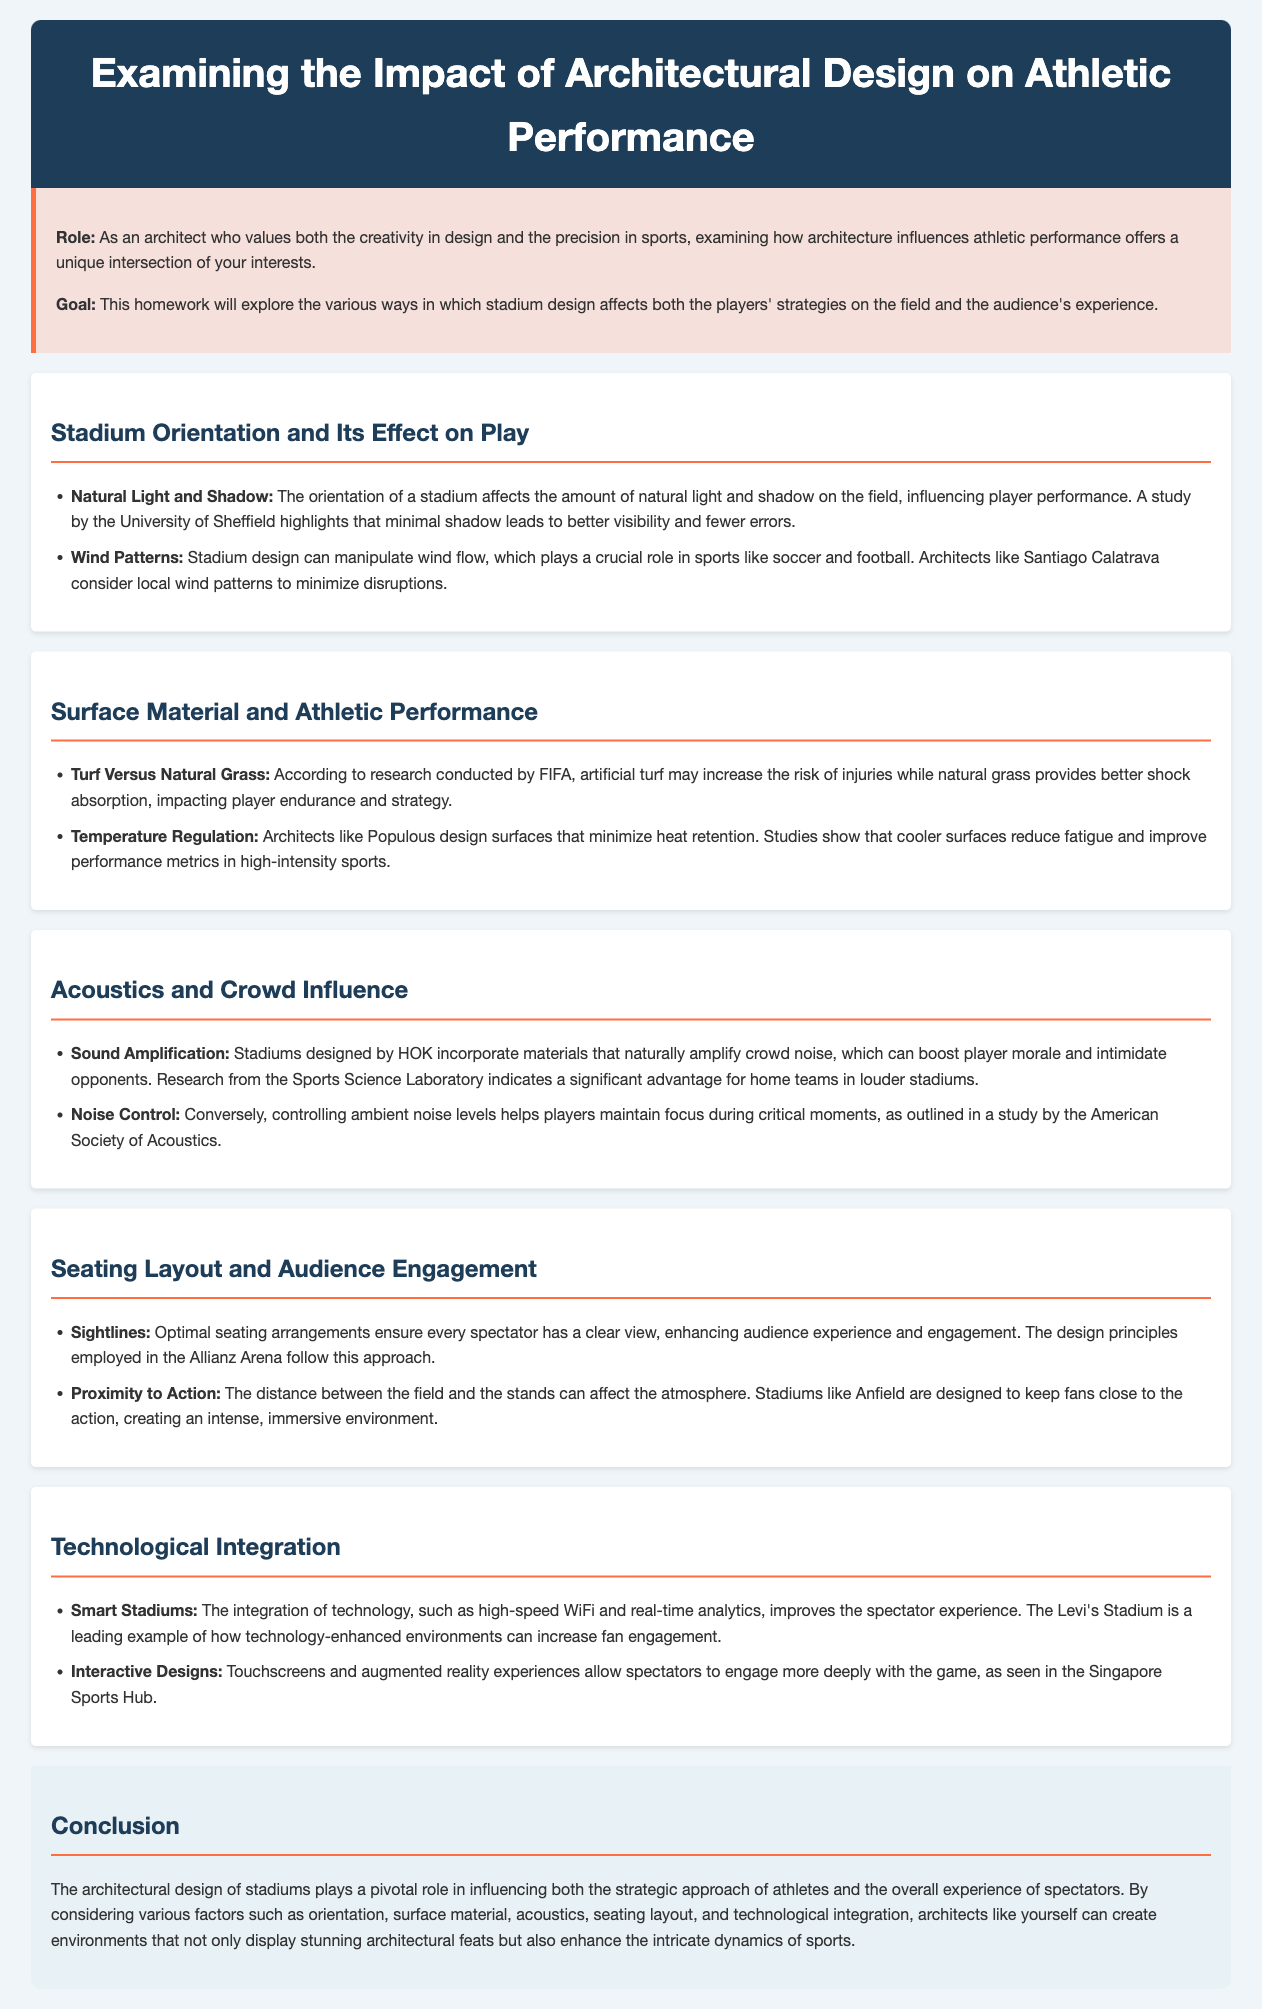What is the primary role of this homework? The primary role of this homework is to explore how stadium design affects player strategies and audience experiences.
Answer: To explore how stadium design affects player strategies and audience experiences Who conducted the study regarding natural light and shadow? The study regarding natural light and shadow was conducted by the University of Sheffield.
Answer: University of Sheffield What material poses a higher risk of injury according to FIFA? According to FIFA, artificial turf poses a higher risk of injury.
Answer: Artificial turf Which architectural firm integrates materials that amplify crowd noise? The architectural firm HOK incorporates materials that amplify crowd noise.
Answer: HOK What design feature enhances audience engagement by ensuring clear views? Optimal sightlines ensure clear views, enhancing audience engagement.
Answer: Optimal sightlines Which stadium is mentioned as an example that keeps fans close to the action? Anfield is mentioned as an example that keeps fans close to the action.
Answer: Anfield What type of technology enhances spectator experience in smart stadiums? High-speed WiFi is an example of technology that enhances spectator experience.
Answer: High-speed WiFi How do architects like Populous mitigate temperature issues on surfaces? Architects like Populous design surfaces that minimize heat retention.
Answer: Minimize heat retention 